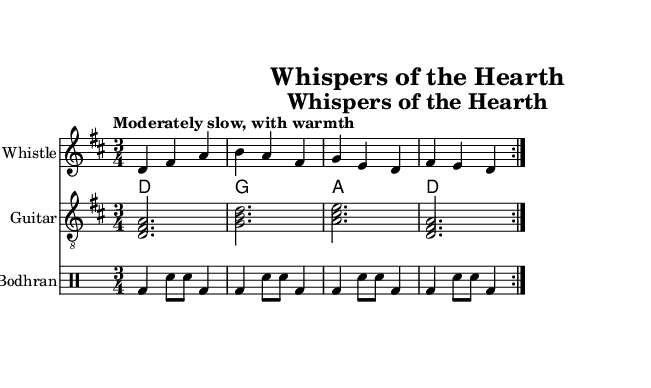What is the title of this piece? The title is indicated in the header section of the sheet music. It reads "Whispers of the Hearth."
Answer: Whispers of the Hearth What is the key signature of this music? The key signature is found right after the clef at the beginning of the staff. It shows two sharps, indicating that the key is D major.
Answer: D major What is the time signature of the music? The time signature is located just after the key signature. It is shown as 3/4, indicating that there are three beats in each measure with a quarter note receiving one beat.
Answer: 3/4 What is the tempo marking for this piece? The tempo marking is written above the staff in a clear font. It states “Moderately slow, with warmth,” indicating the speed and feel of the music.
Answer: Moderately slow, with warmth How many times is the main section repeated? The repeat signs in the music indicate that the main melody should be played two times. This is shown with the volta markings as well.
Answer: 2 What instruments are used in this composition? The instruments are listed at the beginning of each staff. The piece features a Tin Whistle, Guitar, and Bodhran.
Answer: Tin Whistle, Guitar, Bodhran What lyrical theme can be inferred from the opening lines of the lyrics? The lyrics reflect a peaceful and intimate setting, as it mentions the quiet and warmth of a home, which aligns with the folk tradition celebrating hearth and home.
Answer: Peaceful and intimate setting 